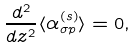<formula> <loc_0><loc_0><loc_500><loc_500>\frac { d ^ { 2 } } { d z ^ { 2 } } \langle \alpha _ { \sigma p } ^ { ( s ) } \rangle = 0 ,</formula> 